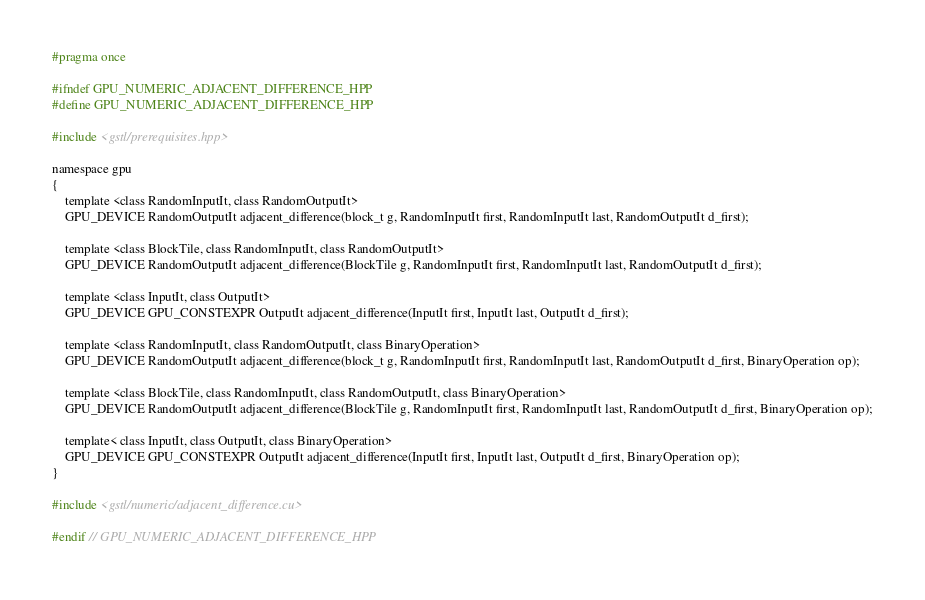Convert code to text. <code><loc_0><loc_0><loc_500><loc_500><_Cuda_>#pragma once

#ifndef GPU_NUMERIC_ADJACENT_DIFFERENCE_HPP
#define GPU_NUMERIC_ADJACENT_DIFFERENCE_HPP

#include <gstl/prerequisites.hpp>

namespace gpu
{
	template <class RandomInputIt, class RandomOutputIt>
	GPU_DEVICE RandomOutputIt adjacent_difference(block_t g, RandomInputIt first, RandomInputIt last, RandomOutputIt d_first);

	template <class BlockTile, class RandomInputIt, class RandomOutputIt>
	GPU_DEVICE RandomOutputIt adjacent_difference(BlockTile g, RandomInputIt first, RandomInputIt last, RandomOutputIt d_first);

	template <class InputIt, class OutputIt>
	GPU_DEVICE GPU_CONSTEXPR OutputIt adjacent_difference(InputIt first, InputIt last, OutputIt d_first);

	template <class RandomInputIt, class RandomOutputIt, class BinaryOperation>
	GPU_DEVICE RandomOutputIt adjacent_difference(block_t g, RandomInputIt first, RandomInputIt last, RandomOutputIt d_first, BinaryOperation op);

	template <class BlockTile, class RandomInputIt, class RandomOutputIt, class BinaryOperation>
	GPU_DEVICE RandomOutputIt adjacent_difference(BlockTile g, RandomInputIt first, RandomInputIt last, RandomOutputIt d_first, BinaryOperation op);

	template< class InputIt, class OutputIt, class BinaryOperation>
	GPU_DEVICE GPU_CONSTEXPR OutputIt adjacent_difference(InputIt first, InputIt last, OutputIt d_first, BinaryOperation op);
}

#include <gstl/numeric/adjacent_difference.cu>

#endif // GPU_NUMERIC_ADJACENT_DIFFERENCE_HPP
</code> 